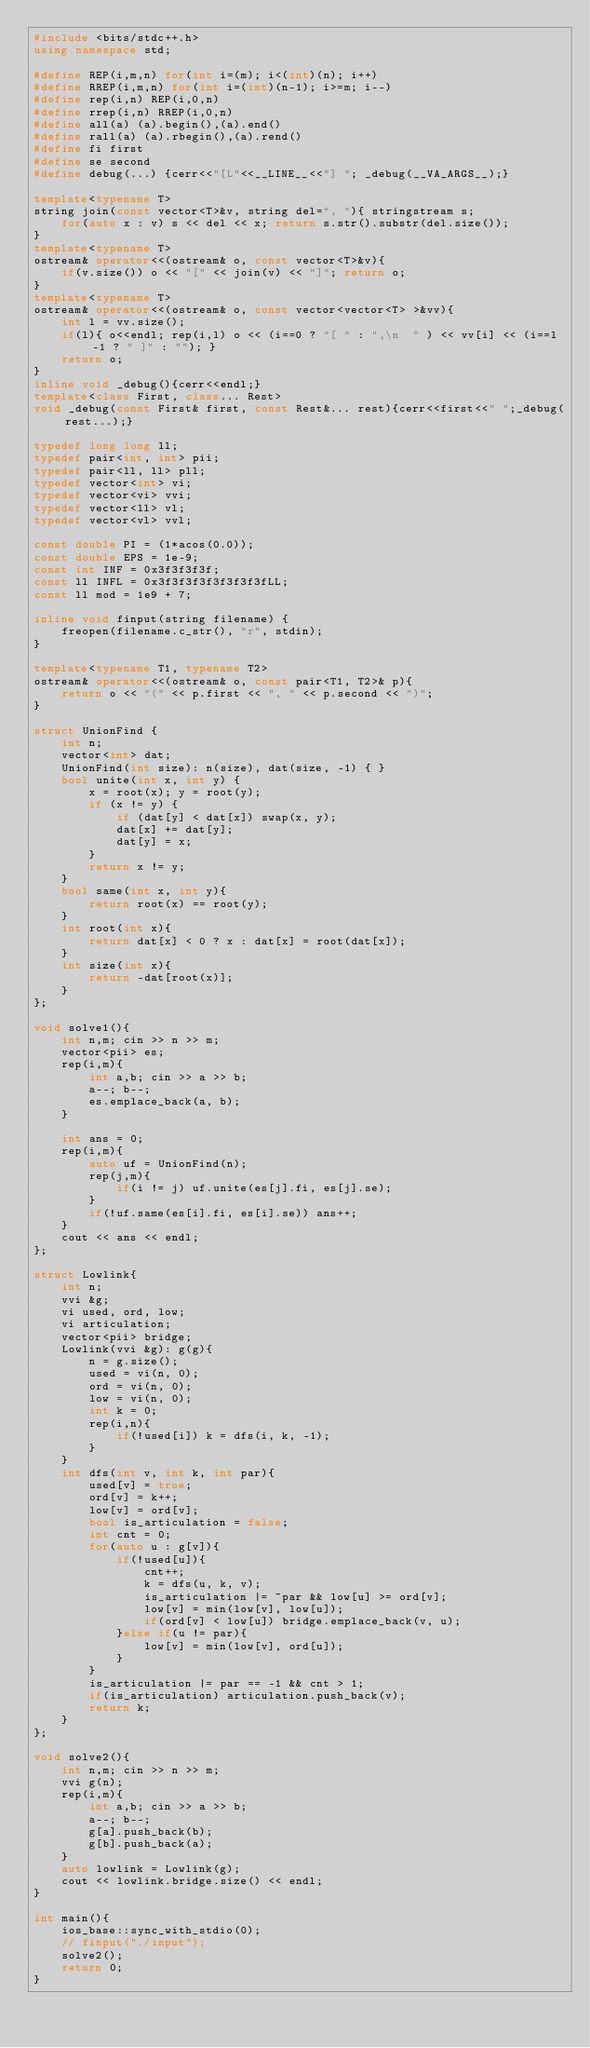<code> <loc_0><loc_0><loc_500><loc_500><_C++_>#include <bits/stdc++.h>
using namespace std;

#define REP(i,m,n) for(int i=(m); i<(int)(n); i++)
#define RREP(i,m,n) for(int i=(int)(n-1); i>=m; i--)
#define rep(i,n) REP(i,0,n)
#define rrep(i,n) RREP(i,0,n)
#define all(a) (a).begin(),(a).end()
#define rall(a) (a).rbegin(),(a).rend()
#define fi first
#define se second
#define debug(...) {cerr<<"[L"<<__LINE__<<"] "; _debug(__VA_ARGS__);}

template<typename T>
string join(const vector<T>&v, string del=", "){ stringstream s;
    for(auto x : v) s << del << x; return s.str().substr(del.size());
}
template<typename T>
ostream& operator<<(ostream& o, const vector<T>&v){
    if(v.size()) o << "[" << join(v) << "]"; return o;
}
template<typename T>
ostream& operator<<(ostream& o, const vector<vector<T> >&vv){
    int l = vv.size();
    if(l){ o<<endl; rep(i,l) o << (i==0 ? "[ " : ",\n  " ) << vv[i] << (i==l-1 ? " ]" : ""); }
    return o;
}
inline void _debug(){cerr<<endl;}
template<class First, class... Rest>
void _debug(const First& first, const Rest&... rest){cerr<<first<<" ";_debug(rest...);}

typedef long long ll;
typedef pair<int, int> pii;
typedef pair<ll, ll> pll;
typedef vector<int> vi;
typedef vector<vi> vvi;
typedef vector<ll> vl;
typedef vector<vl> vvl;

const double PI = (1*acos(0.0));
const double EPS = 1e-9;
const int INF = 0x3f3f3f3f;
const ll INFL = 0x3f3f3f3f3f3f3f3fLL;
const ll mod = 1e9 + 7;

inline void finput(string filename) {
    freopen(filename.c_str(), "r", stdin);
}

template<typename T1, typename T2>
ostream& operator<<(ostream& o, const pair<T1, T2>& p){
    return o << "(" << p.first << ", " << p.second << ")";
}

struct UnionFind {
    int n;
    vector<int> dat;
    UnionFind(int size): n(size), dat(size, -1) { }
    bool unite(int x, int y) {
        x = root(x); y = root(y);
        if (x != y) {
            if (dat[y] < dat[x]) swap(x, y);
            dat[x] += dat[y];
            dat[y] = x;
        }
        return x != y;
    }
    bool same(int x, int y){
        return root(x) == root(y);
    }
    int root(int x){
        return dat[x] < 0 ? x : dat[x] = root(dat[x]);
    }
    int size(int x){
        return -dat[root(x)];
    }
};

void solve1(){
    int n,m; cin >> n >> m;
    vector<pii> es;
    rep(i,m){
        int a,b; cin >> a >> b;
        a--; b--;
        es.emplace_back(a, b);
    }

    int ans = 0;
    rep(i,m){
        auto uf = UnionFind(n);
        rep(j,m){
            if(i != j) uf.unite(es[j].fi, es[j].se);
        }
        if(!uf.same(es[i].fi, es[i].se)) ans++;
    }
    cout << ans << endl;
};

struct Lowlink{
    int n;
    vvi &g;
    vi used, ord, low;
    vi articulation;
    vector<pii> bridge;
    Lowlink(vvi &g): g(g){
        n = g.size();
        used = vi(n, 0);
        ord = vi(n, 0);
        low = vi(n, 0);
        int k = 0;
        rep(i,n){
            if(!used[i]) k = dfs(i, k, -1);
        }
    }
    int dfs(int v, int k, int par){
        used[v] = true;
        ord[v] = k++;
        low[v] = ord[v];
        bool is_articulation = false;
        int cnt = 0;
        for(auto u : g[v]){
            if(!used[u]){
                cnt++;
                k = dfs(u, k, v);
                is_articulation |= ~par && low[u] >= ord[v];
                low[v] = min(low[v], low[u]);
                if(ord[v] < low[u]) bridge.emplace_back(v, u);
            }else if(u != par){
                low[v] = min(low[v], ord[u]);
            }
        }
        is_articulation |= par == -1 && cnt > 1;
        if(is_articulation) articulation.push_back(v);
        return k;
    }
};

void solve2(){
    int n,m; cin >> n >> m;
    vvi g(n);
    rep(i,m){
        int a,b; cin >> a >> b;
        a--; b--;
        g[a].push_back(b);
        g[b].push_back(a);
    }
    auto lowlink = Lowlink(g);
    cout << lowlink.bridge.size() << endl;
}

int main(){
    ios_base::sync_with_stdio(0);
    // finput("./input");
    solve2();
    return 0;
}</code> 